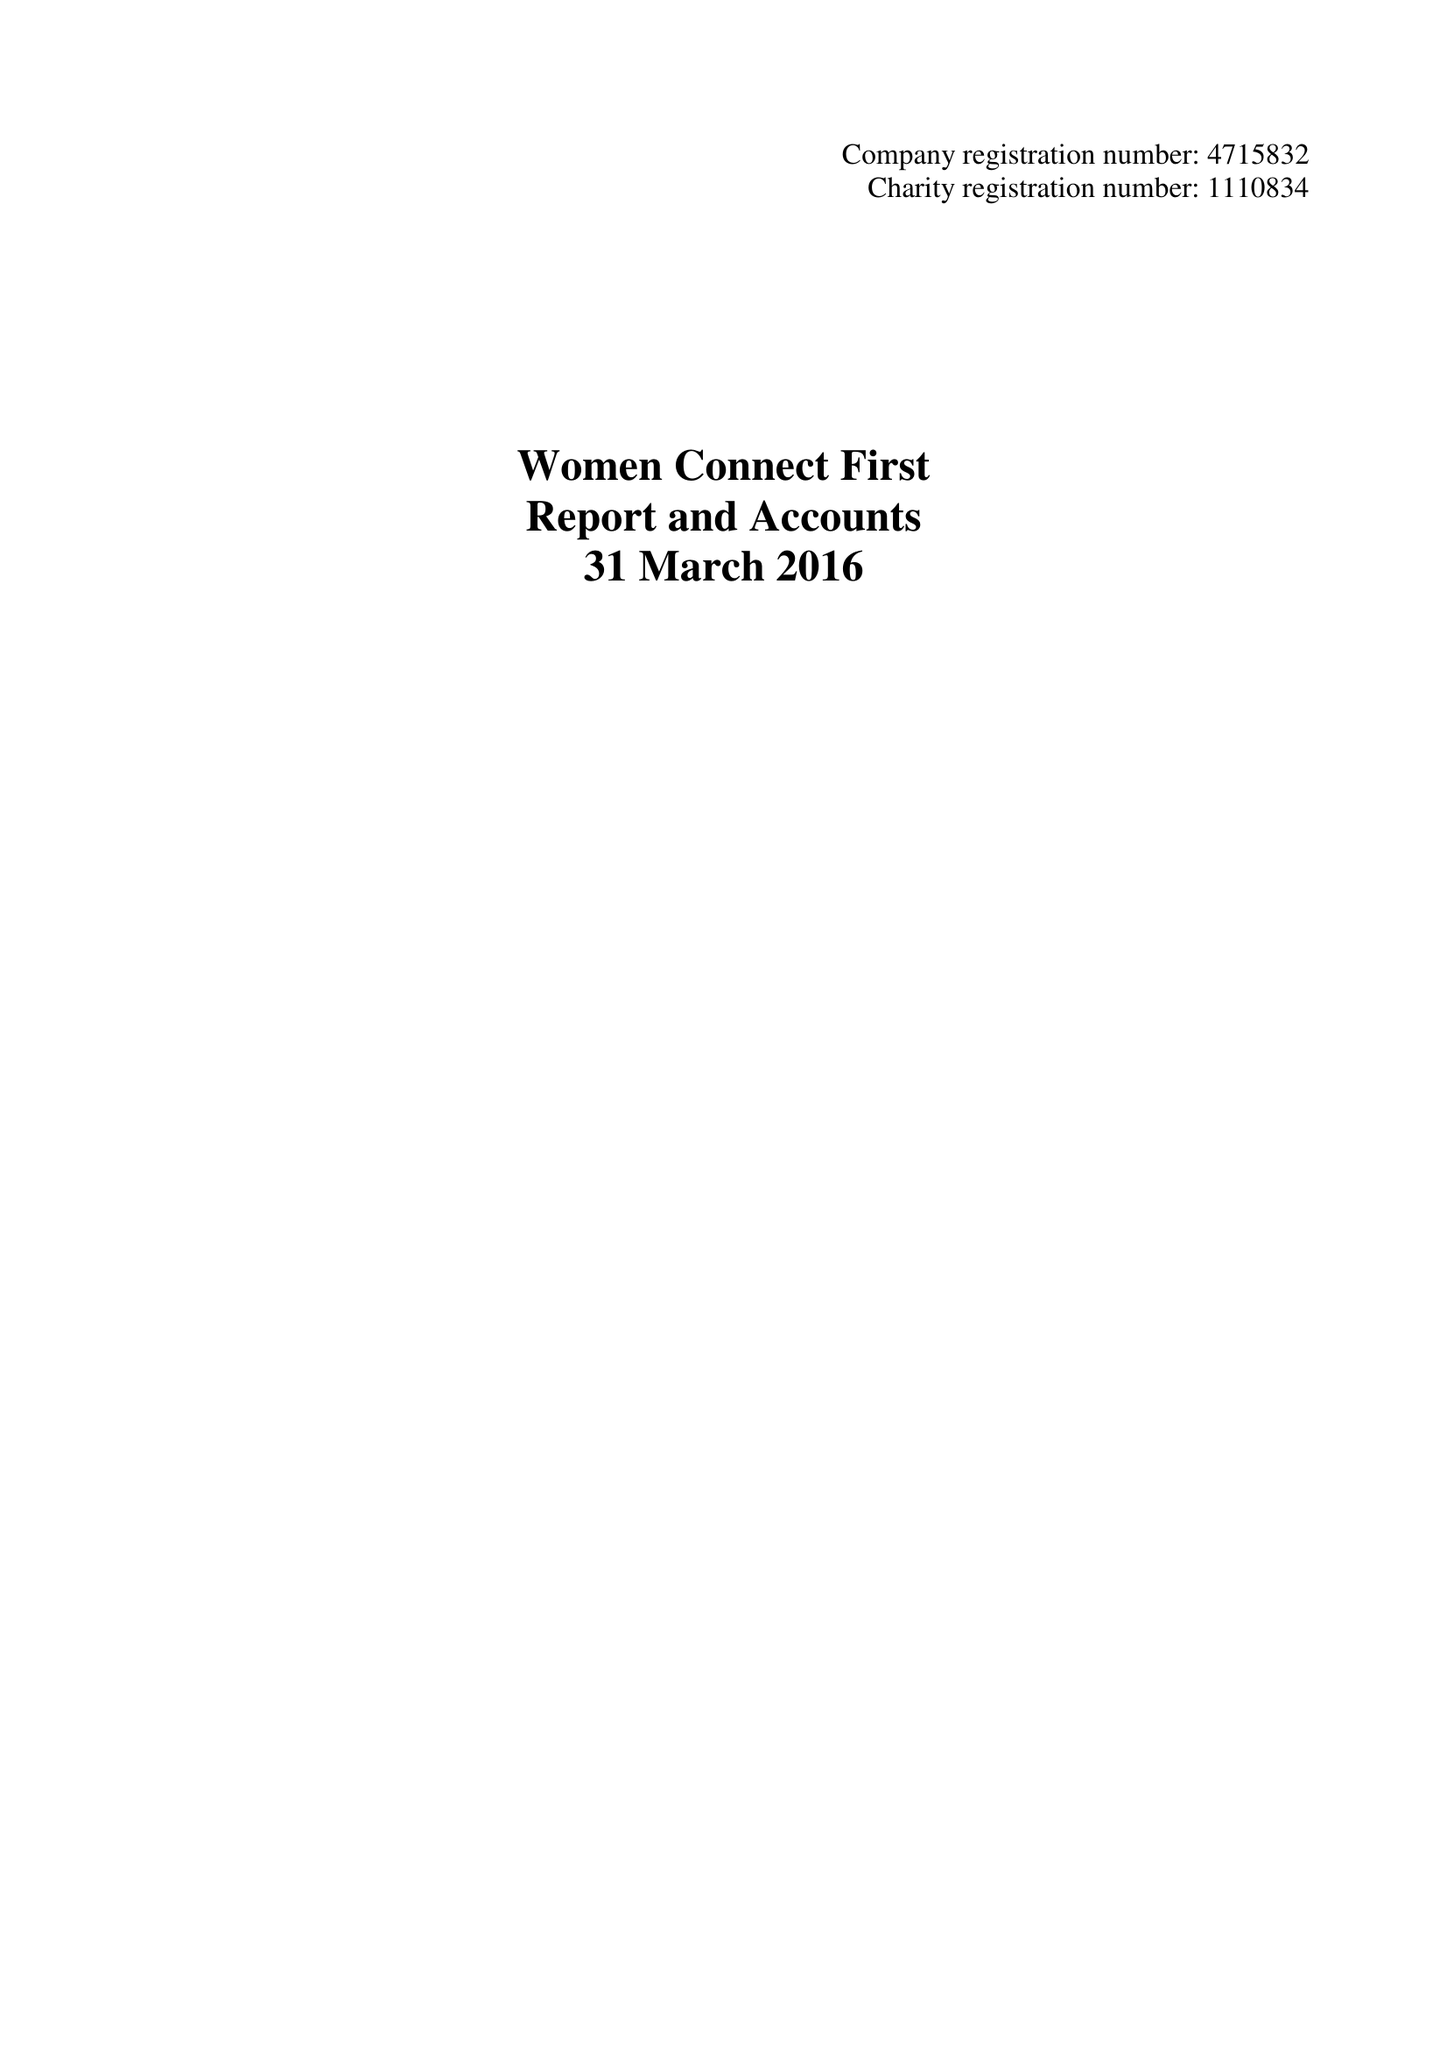What is the value for the income_annually_in_british_pounds?
Answer the question using a single word or phrase. 346389.00 